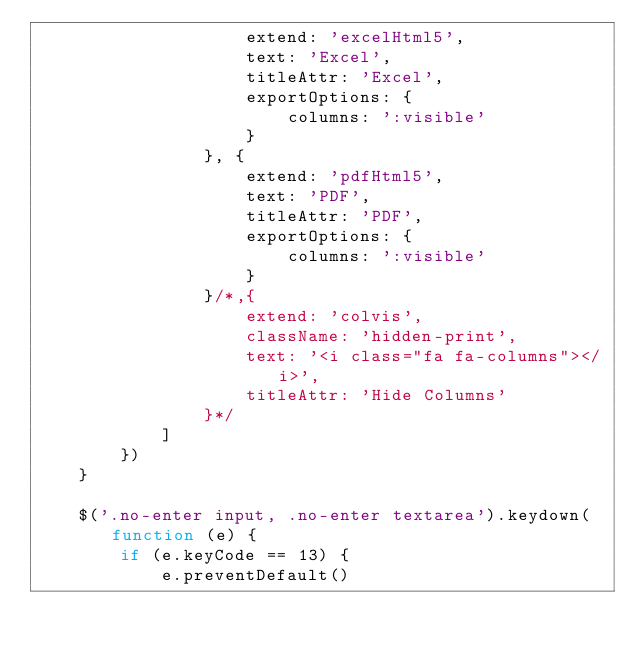Convert code to text. <code><loc_0><loc_0><loc_500><loc_500><_JavaScript_>                    extend: 'excelHtml5',
                    text: 'Excel',
                    titleAttr: 'Excel',
                    exportOptions: {
                        columns: ':visible'
                    }
                }, {
                    extend: 'pdfHtml5',
                    text: 'PDF',
                    titleAttr: 'PDF',
                    exportOptions: {
                        columns: ':visible'
                    }
                }/*,{
                    extend: 'colvis',
                    className: 'hidden-print',
                    text: '<i class="fa fa-columns"></i>',
                    titleAttr: 'Hide Columns'
                }*/
            ]
        })
    }

    $('.no-enter input, .no-enter textarea').keydown(function (e) {
        if (e.keyCode == 13) {
            e.preventDefault()</code> 